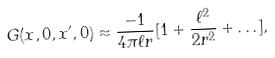Convert formula to latex. <formula><loc_0><loc_0><loc_500><loc_500>G ( x , 0 , x ^ { \prime } , 0 ) \approx \frac { - 1 } { 4 \pi \ell r } [ 1 + \frac { \ell ^ { 2 } } { 2 r ^ { 2 } } + \dots ] ,</formula> 